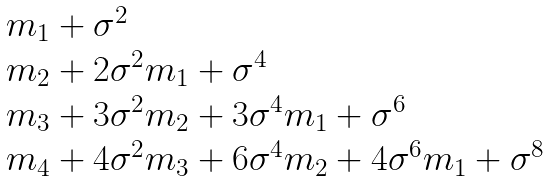Convert formula to latex. <formula><loc_0><loc_0><loc_500><loc_500>\begin{array} { l l } & m _ { 1 } + { \sigma } ^ { 2 } \\ & m _ { 2 } + 2 { \sigma } ^ { 2 } m _ { 1 } + { \sigma } ^ { 4 } \\ & m _ { 3 } + 3 { \sigma } ^ { 2 } m _ { 2 } + 3 { \sigma } ^ { 4 } m _ { 1 } + { \sigma } ^ { 6 } \\ & m _ { 4 } + 4 \sigma ^ { 2 } m _ { 3 } + 6 { \sigma } ^ { 4 } m _ { 2 } + 4 { \sigma } ^ { 6 } m _ { 1 } + { \sigma } ^ { 8 } \end{array}</formula> 